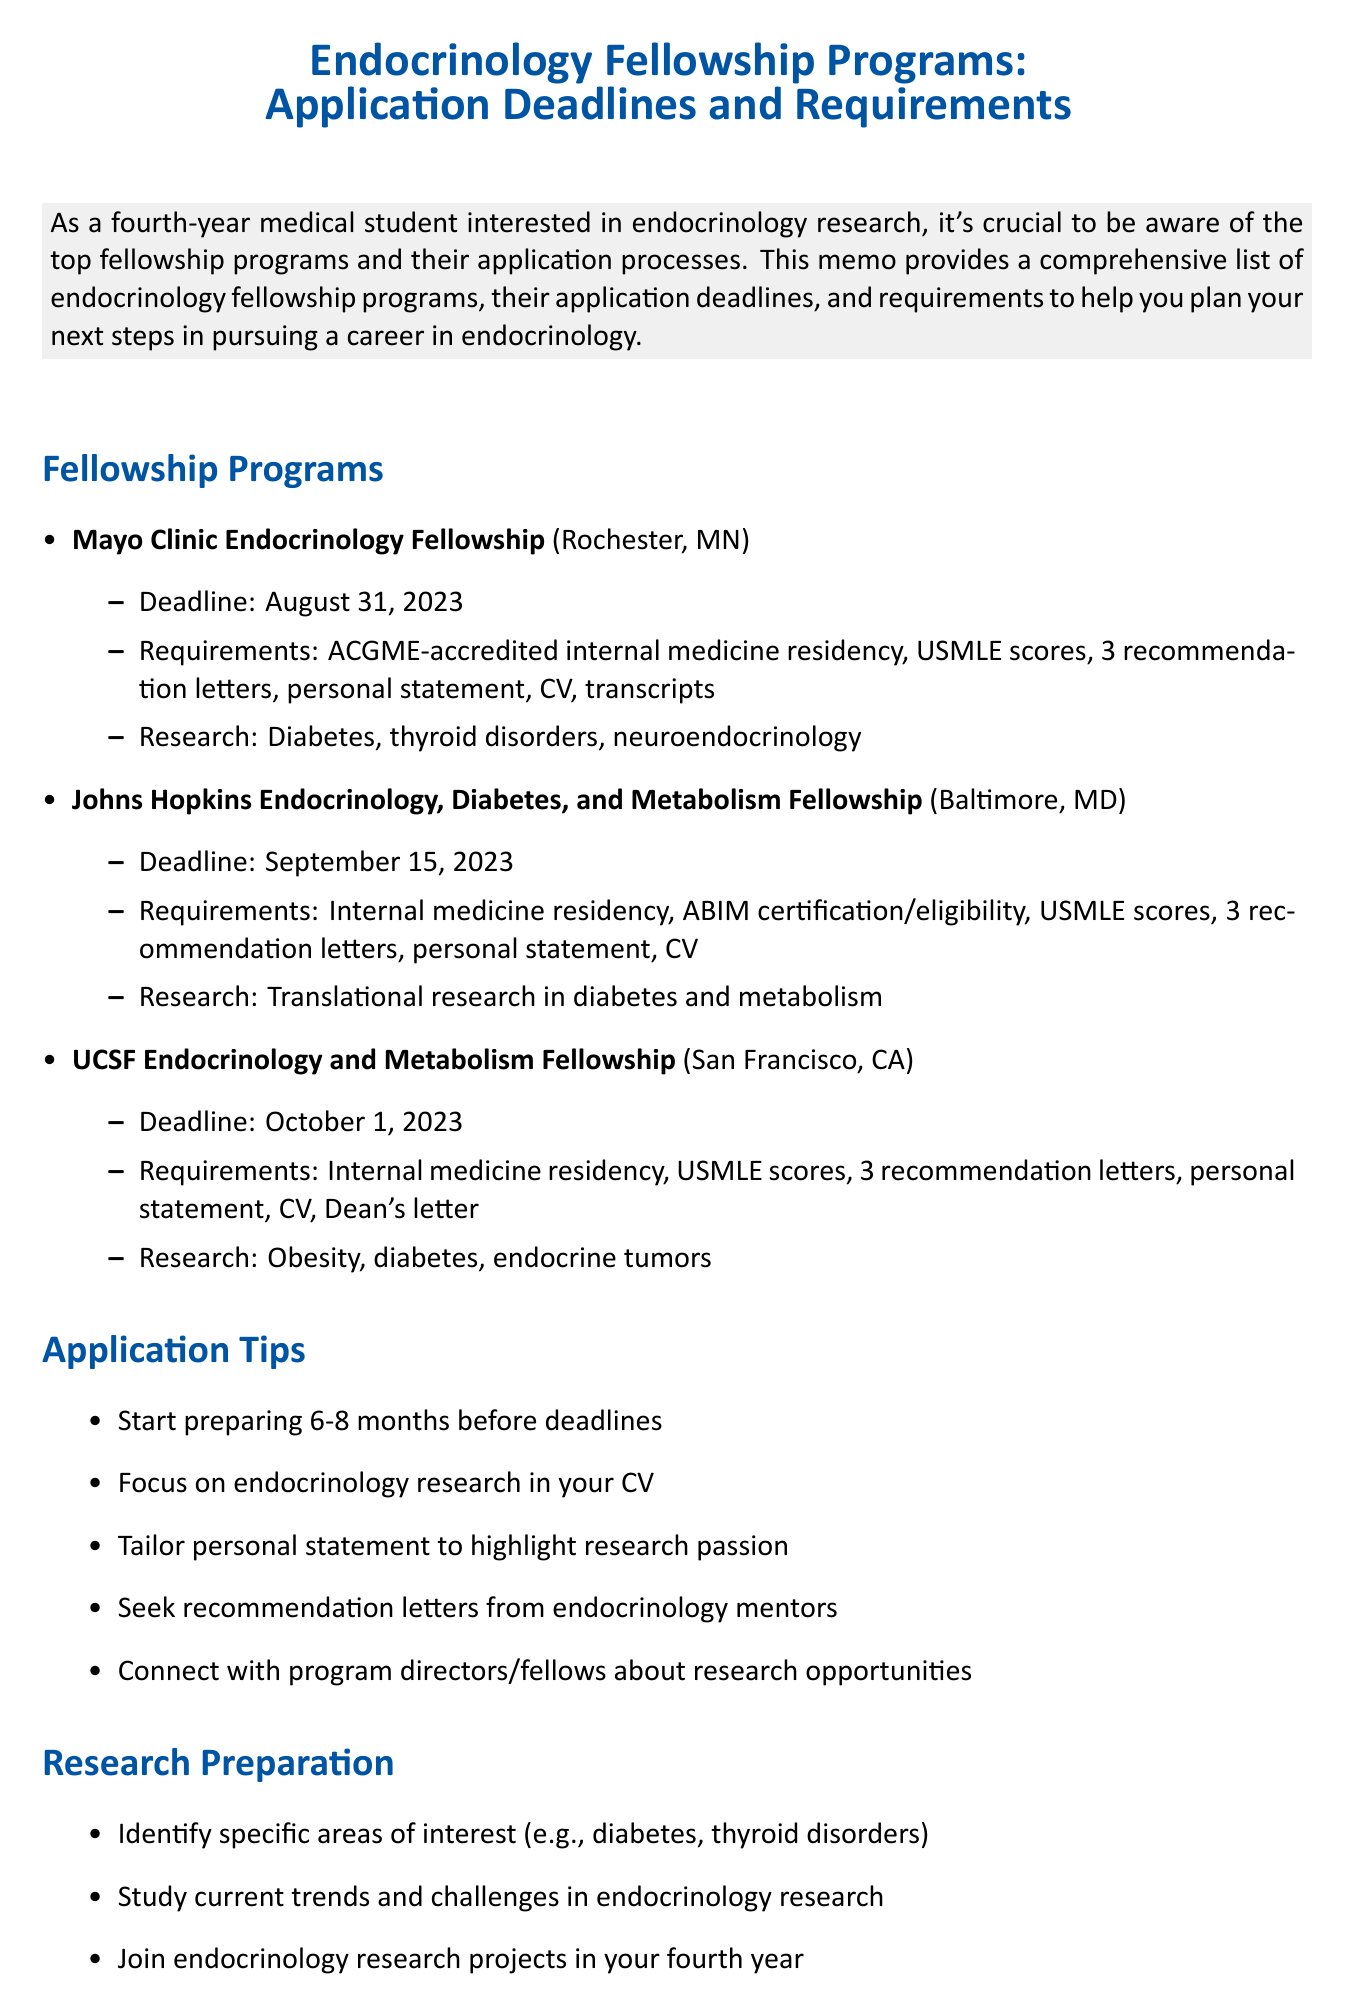What is the application deadline for the Mayo Clinic Endocrinology Fellowship? The application deadline for the Mayo Clinic Endocrinology Fellowship is stated in the document.
Answer: August 31, 2023 What location is associated with the UCSF Endocrinology and Metabolism Fellowship? The location can be found under the fellowship program details for UCSF in the document.
Answer: San Francisco, CA What is one requirement for the Johns Hopkins Endocrinology Fellowship? The document lists specific requirements for each fellowship program, including the Johns Hopkins Fellowship.
Answer: ABIM certification or eligibility What type of research opportunities does the Mayo Clinic Endocrinology Fellowship offer? The document mentions the research opportunities associated with the Mayo Clinic fellowship.
Answer: Extensive research opportunities in diabetes, thyroid disorders, and neuroendocrinology How many letters of recommendation are required for the UCSF Endocrinology fellowship? The number of letters of recommendation required for the UCSF fellowship is listed in the requirements section.
Answer: Three letters of recommendation What is a suggested application tip mentioned in the memo? The memo provides tips for preparing applications, highlighting the importance of early preparation.
Answer: Start preparing your application materials early, ideally 6-8 months before deadlines Which area of interest should you identify according to the research preparation section? The document suggests identifying specific areas of interest in endocrinology for better research focus.
Answer: Specific areas of interest within endocrinology What type of research is emphasized in the Johns Hopkins fellowship? The document specifies the focus of research opportunities offered by the Johns Hopkins fellowship program.
Answer: Translational research in diabetes and metabolism 